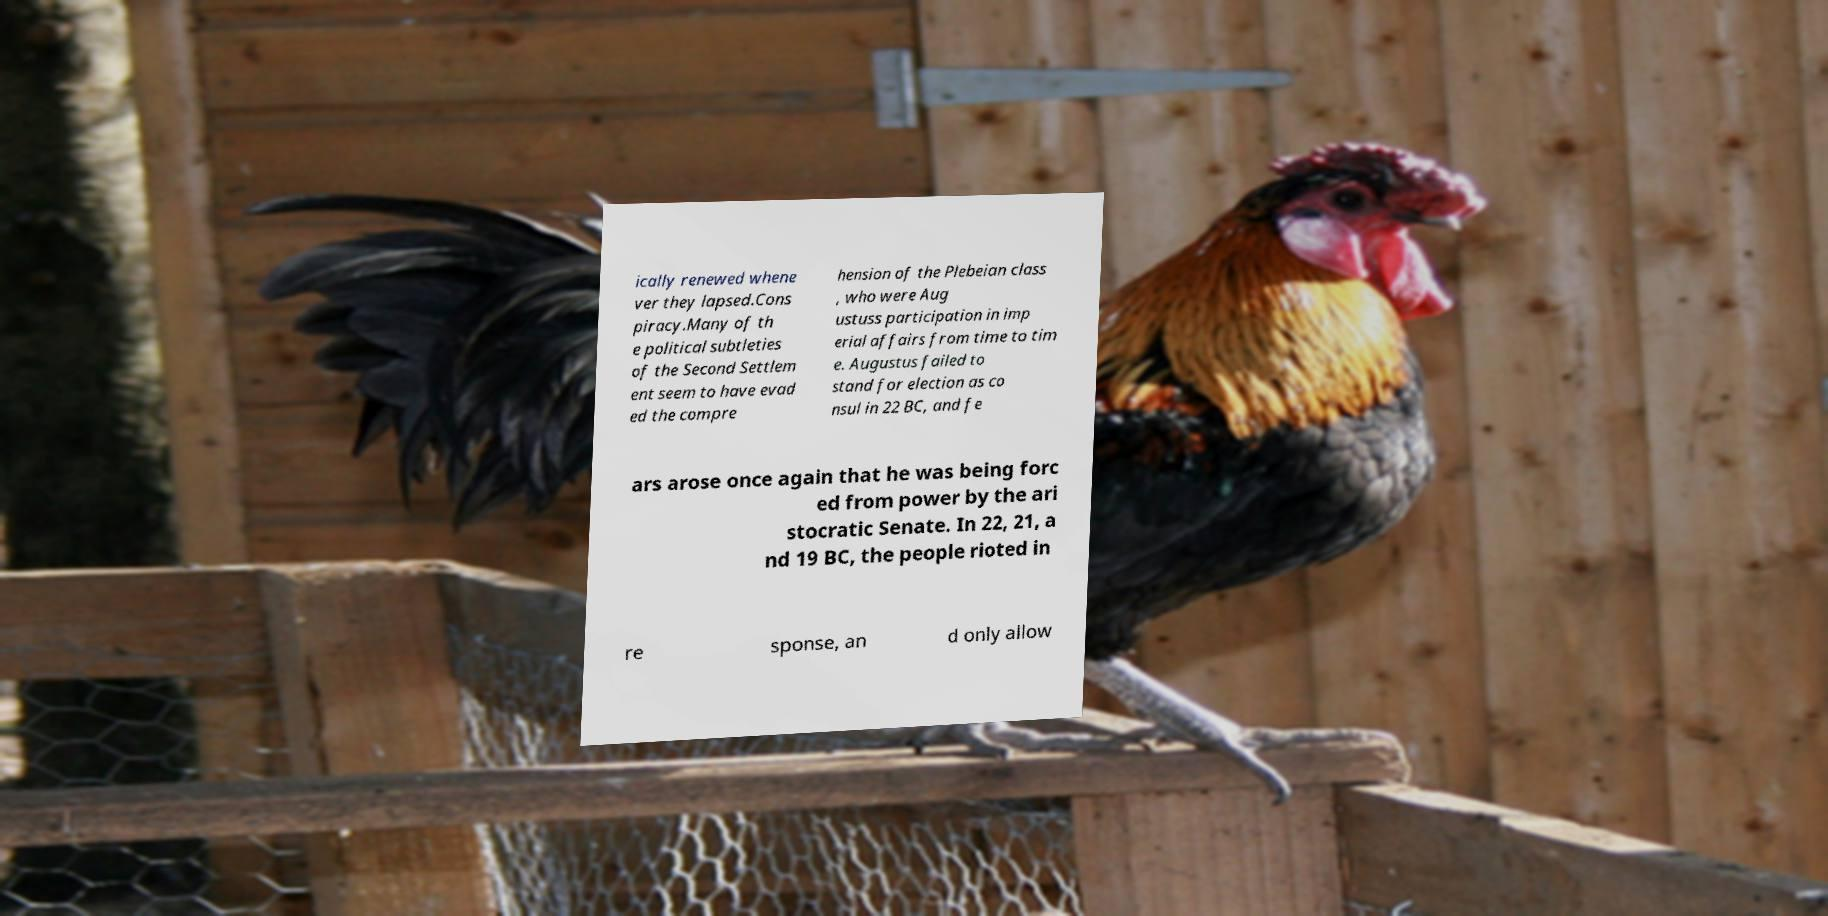There's text embedded in this image that I need extracted. Can you transcribe it verbatim? ically renewed whene ver they lapsed.Cons piracy.Many of th e political subtleties of the Second Settlem ent seem to have evad ed the compre hension of the Plebeian class , who were Aug ustuss participation in imp erial affairs from time to tim e. Augustus failed to stand for election as co nsul in 22 BC, and fe ars arose once again that he was being forc ed from power by the ari stocratic Senate. In 22, 21, a nd 19 BC, the people rioted in re sponse, an d only allow 